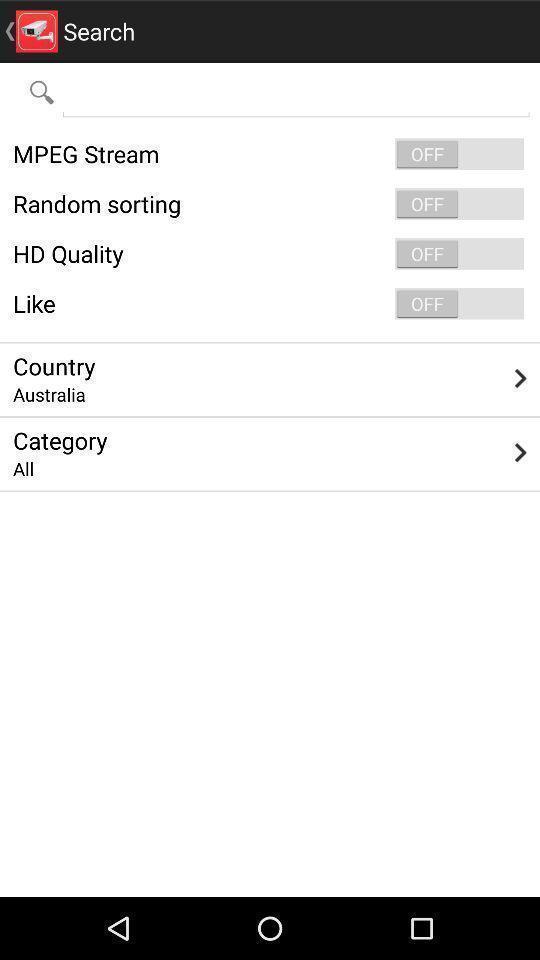Give me a narrative description of this picture. Search page with various options. 